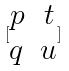<formula> <loc_0><loc_0><loc_500><loc_500>[ \begin{matrix} p & t \\ q & u \end{matrix} ]</formula> 